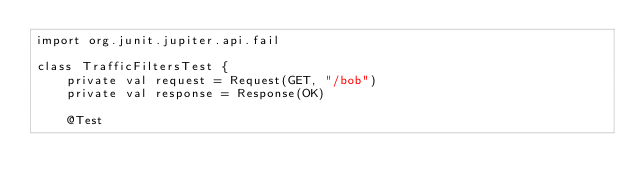<code> <loc_0><loc_0><loc_500><loc_500><_Kotlin_>import org.junit.jupiter.api.fail

class TrafficFiltersTest {
    private val request = Request(GET, "/bob")
    private val response = Response(OK)

    @Test</code> 